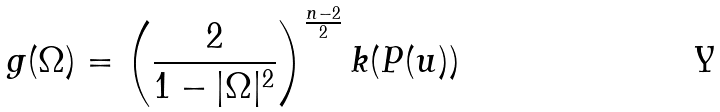<formula> <loc_0><loc_0><loc_500><loc_500>g ( \Omega ) = \left ( \frac { 2 } { 1 - | \Omega | ^ { 2 } } \right ) ^ { \frac { n - 2 } { 2 } } k ( P ( u ) )</formula> 